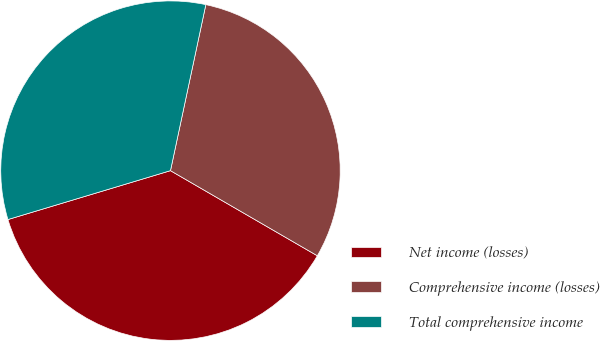Convert chart. <chart><loc_0><loc_0><loc_500><loc_500><pie_chart><fcel>Net income (losses)<fcel>Comprehensive income (losses)<fcel>Total comprehensive income<nl><fcel>36.99%<fcel>30.02%<fcel>32.99%<nl></chart> 